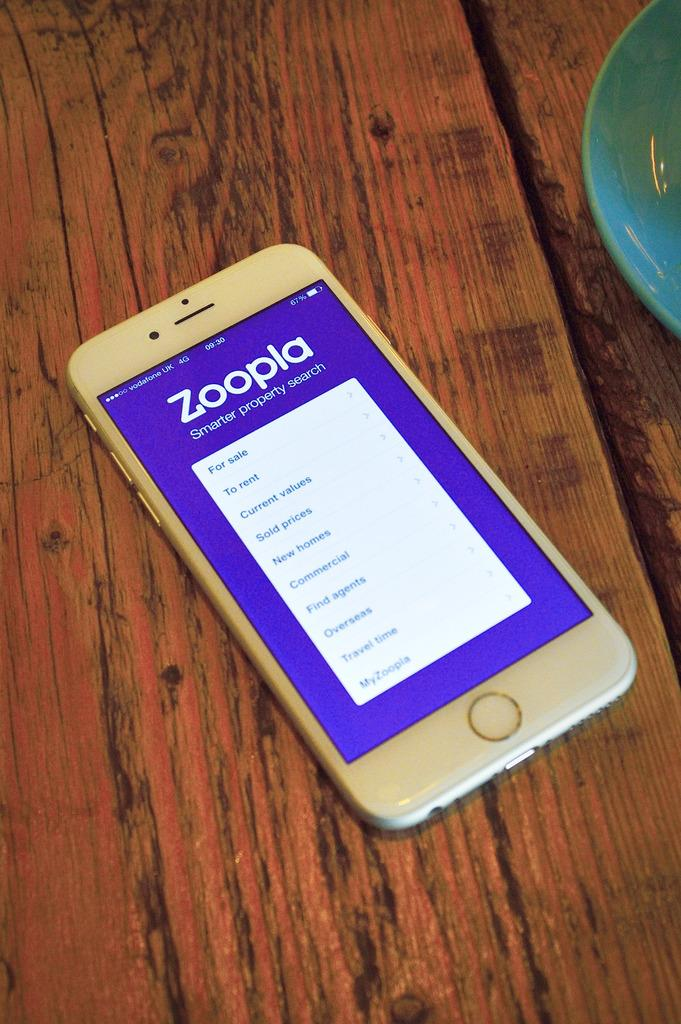Provide a one-sentence caption for the provided image. a cellphone on a wooden table with zoopia on the screen. 